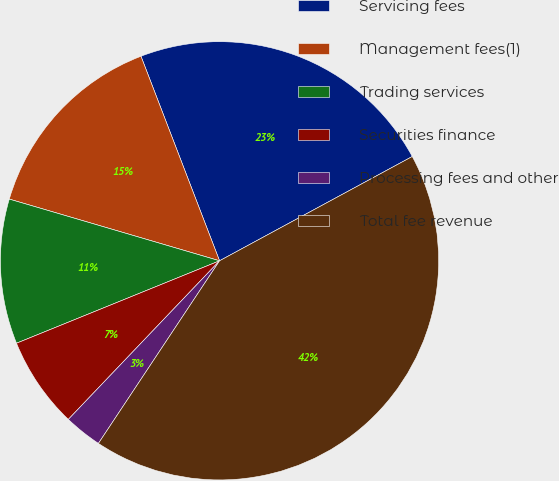Convert chart to OTSL. <chart><loc_0><loc_0><loc_500><loc_500><pie_chart><fcel>Servicing fees<fcel>Management fees(1)<fcel>Trading services<fcel>Securities finance<fcel>Processing fees and other<fcel>Total fee revenue<nl><fcel>22.94%<fcel>14.62%<fcel>10.68%<fcel>6.74%<fcel>2.8%<fcel>42.21%<nl></chart> 